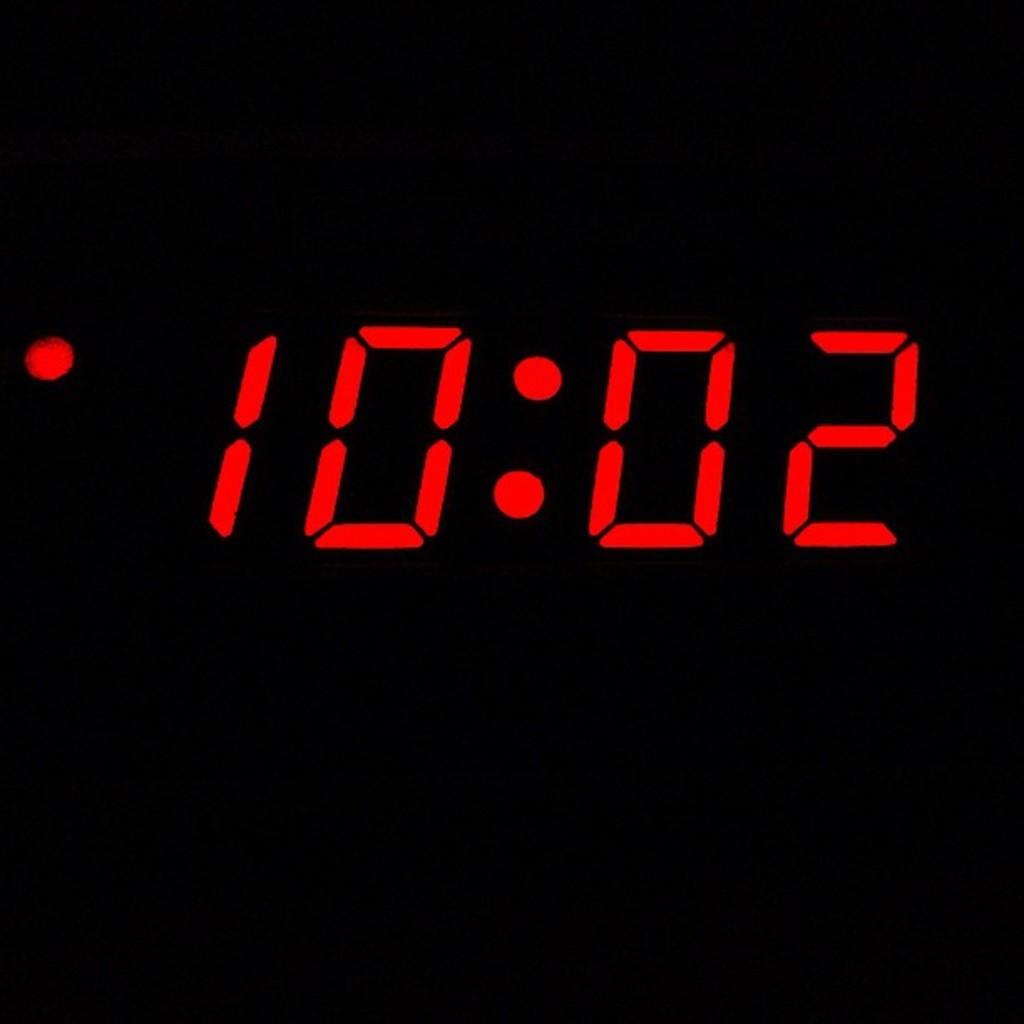What time is it?
Your answer should be very brief. 10:02. What time is it?
Ensure brevity in your answer.  10:02. 